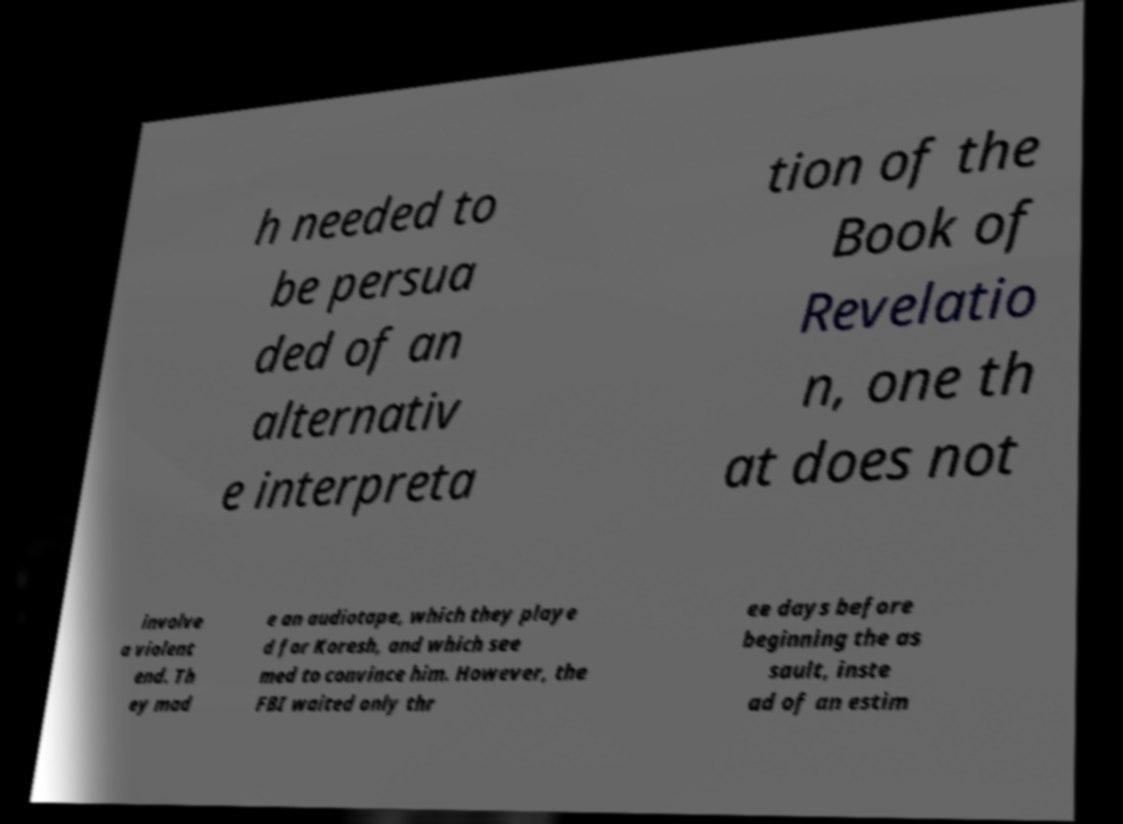What messages or text are displayed in this image? I need them in a readable, typed format. h needed to be persua ded of an alternativ e interpreta tion of the Book of Revelatio n, one th at does not involve a violent end. Th ey mad e an audiotape, which they playe d for Koresh, and which see med to convince him. However, the FBI waited only thr ee days before beginning the as sault, inste ad of an estim 